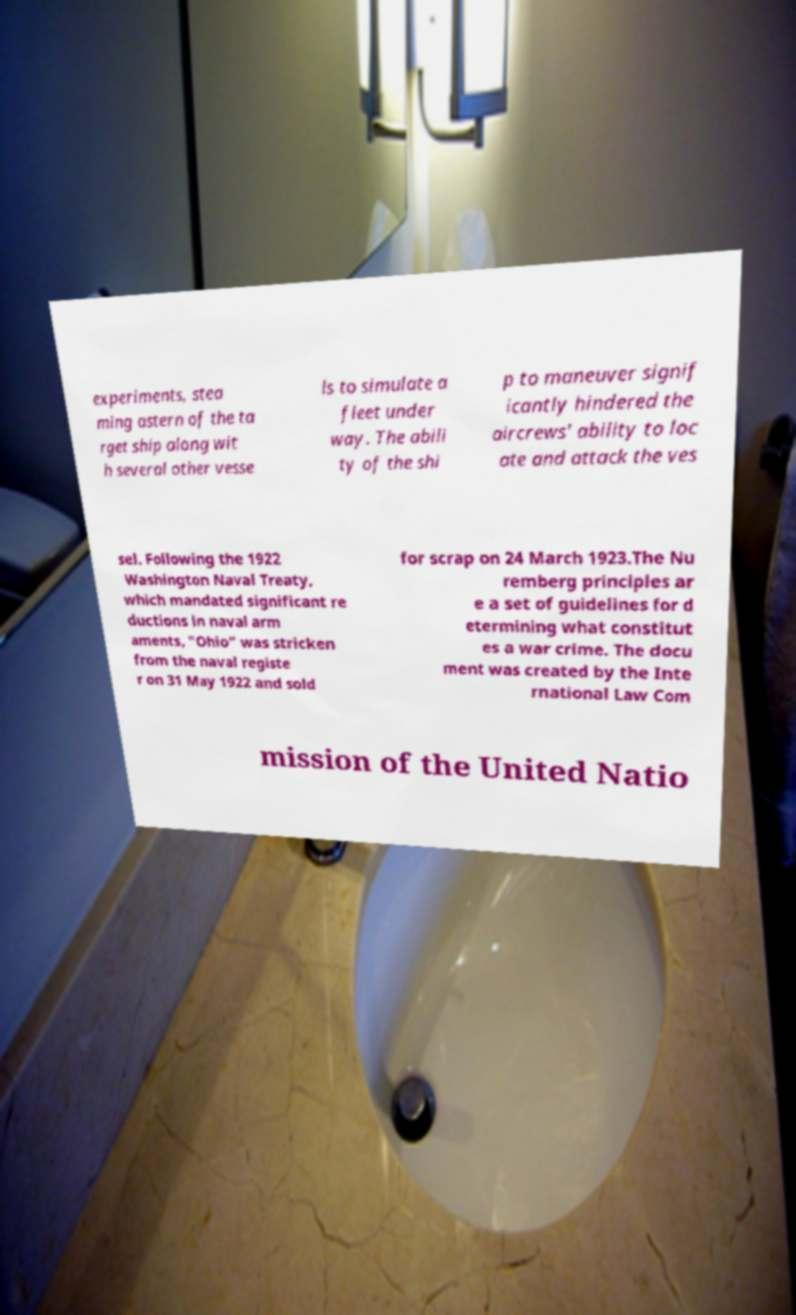Can you read and provide the text displayed in the image?This photo seems to have some interesting text. Can you extract and type it out for me? experiments, stea ming astern of the ta rget ship along wit h several other vesse ls to simulate a fleet under way. The abili ty of the shi p to maneuver signif icantly hindered the aircrews' ability to loc ate and attack the ves sel. Following the 1922 Washington Naval Treaty, which mandated significant re ductions in naval arm aments, "Ohio" was stricken from the naval registe r on 31 May 1922 and sold for scrap on 24 March 1923.The Nu remberg principles ar e a set of guidelines for d etermining what constitut es a war crime. The docu ment was created by the Inte rnational Law Com mission of the United Natio 